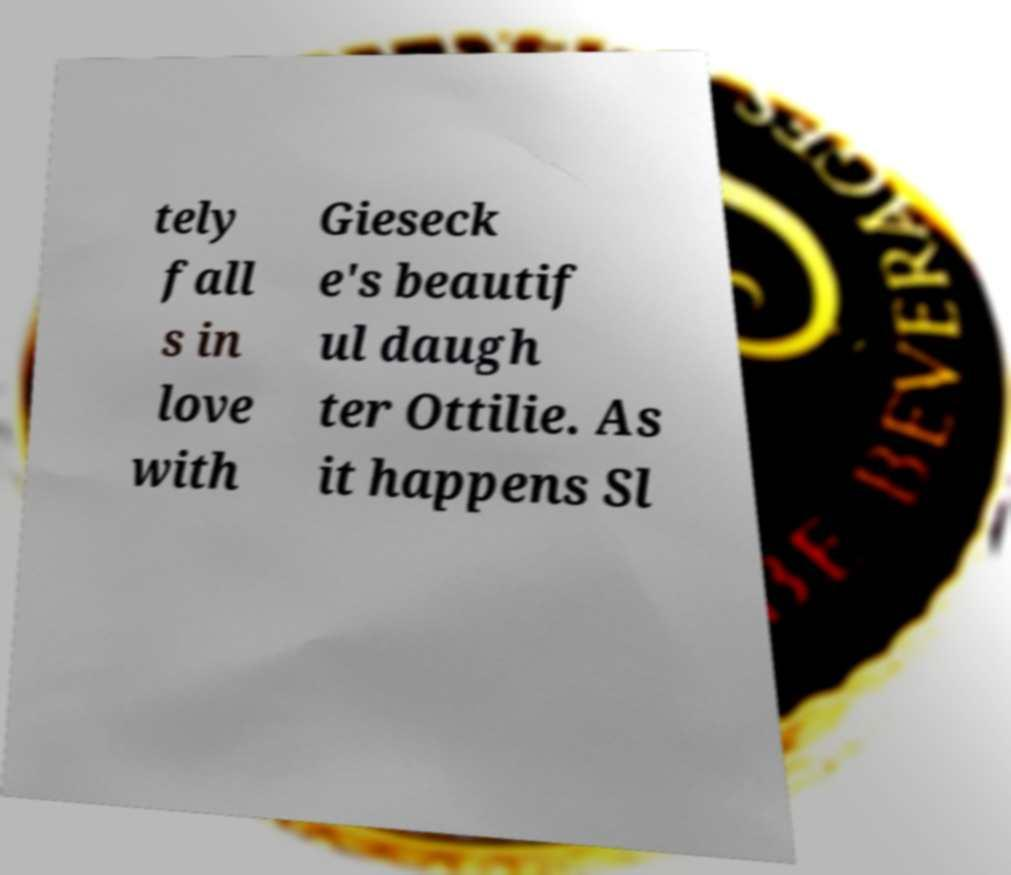Please read and relay the text visible in this image. What does it say? tely fall s in love with Gieseck e's beautif ul daugh ter Ottilie. As it happens Sl 